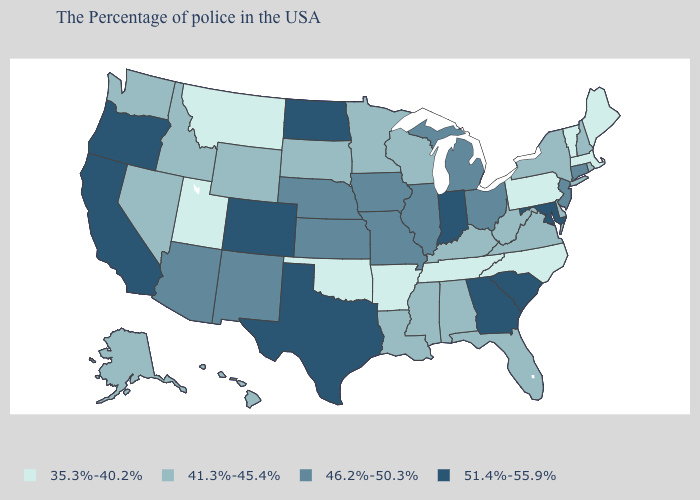Does the map have missing data?
Concise answer only. No. What is the highest value in the South ?
Short answer required. 51.4%-55.9%. What is the value of Wyoming?
Short answer required. 41.3%-45.4%. What is the value of Connecticut?
Answer briefly. 46.2%-50.3%. What is the value of South Dakota?
Keep it brief. 41.3%-45.4%. Name the states that have a value in the range 51.4%-55.9%?
Keep it brief. Maryland, South Carolina, Georgia, Indiana, Texas, North Dakota, Colorado, California, Oregon. What is the value of Oklahoma?
Keep it brief. 35.3%-40.2%. Name the states that have a value in the range 41.3%-45.4%?
Be succinct. Rhode Island, New Hampshire, New York, Delaware, Virginia, West Virginia, Florida, Kentucky, Alabama, Wisconsin, Mississippi, Louisiana, Minnesota, South Dakota, Wyoming, Idaho, Nevada, Washington, Alaska, Hawaii. What is the highest value in states that border Massachusetts?
Be succinct. 46.2%-50.3%. Which states have the lowest value in the USA?
Concise answer only. Maine, Massachusetts, Vermont, Pennsylvania, North Carolina, Tennessee, Arkansas, Oklahoma, Utah, Montana. Among the states that border Louisiana , does Mississippi have the highest value?
Quick response, please. No. Name the states that have a value in the range 41.3%-45.4%?
Be succinct. Rhode Island, New Hampshire, New York, Delaware, Virginia, West Virginia, Florida, Kentucky, Alabama, Wisconsin, Mississippi, Louisiana, Minnesota, South Dakota, Wyoming, Idaho, Nevada, Washington, Alaska, Hawaii. What is the lowest value in the West?
Give a very brief answer. 35.3%-40.2%. What is the value of Connecticut?
Be succinct. 46.2%-50.3%. Name the states that have a value in the range 46.2%-50.3%?
Answer briefly. Connecticut, New Jersey, Ohio, Michigan, Illinois, Missouri, Iowa, Kansas, Nebraska, New Mexico, Arizona. 